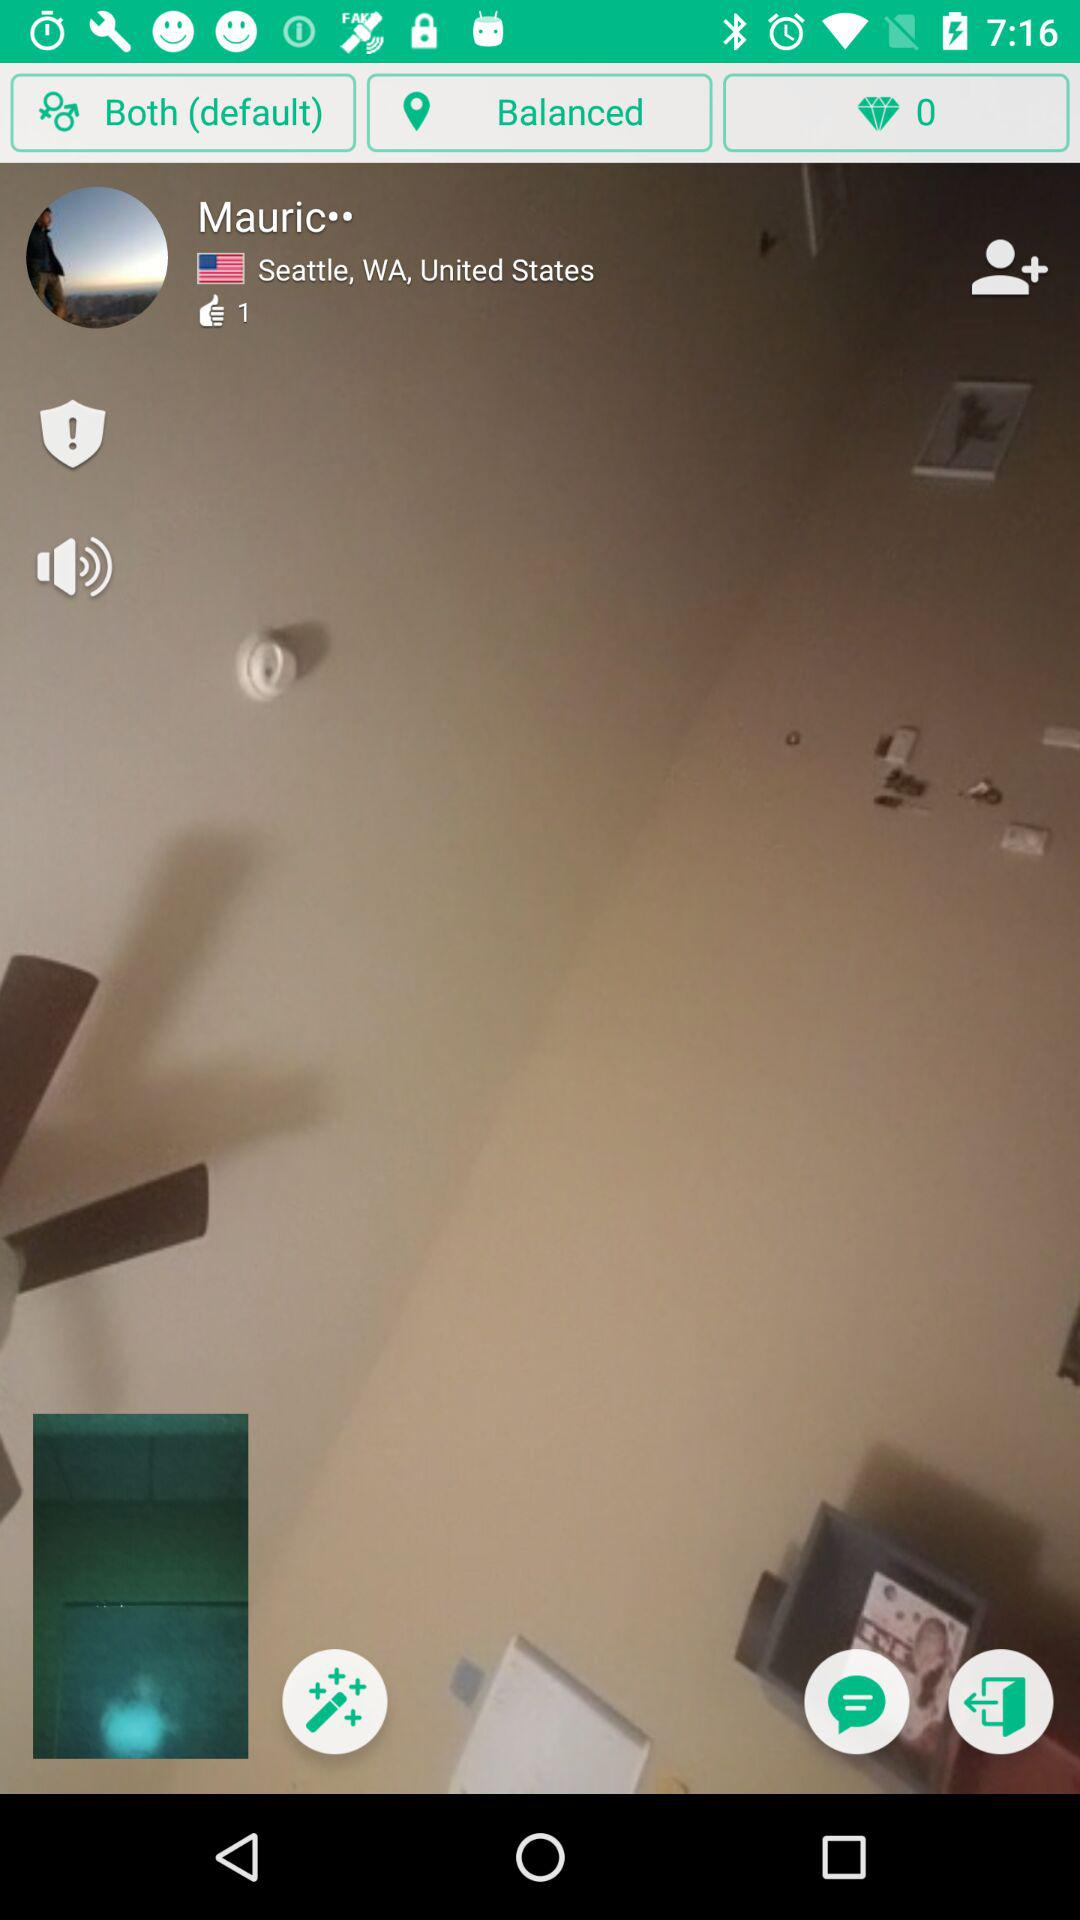What is the user name? The user name is Mauric. 